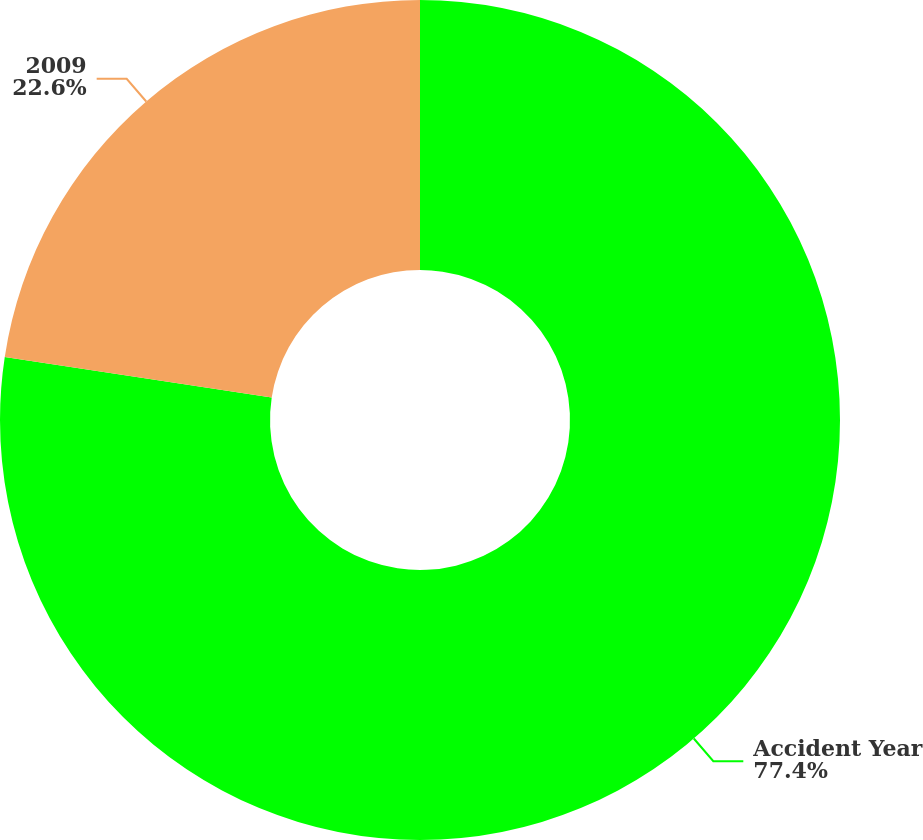<chart> <loc_0><loc_0><loc_500><loc_500><pie_chart><fcel>Accident Year<fcel>2009<nl><fcel>77.4%<fcel>22.6%<nl></chart> 